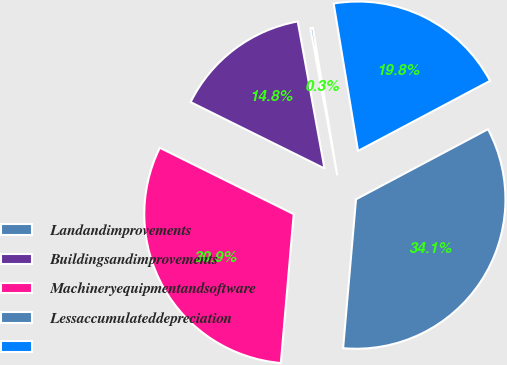<chart> <loc_0><loc_0><loc_500><loc_500><pie_chart><fcel>Landandimprovements<fcel>Buildingsandimprovements<fcel>Machineryequipmentandsoftware<fcel>Lessaccumulateddepreciation<fcel>Unnamed: 4<nl><fcel>0.26%<fcel>14.81%<fcel>30.95%<fcel>34.15%<fcel>19.84%<nl></chart> 